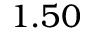<formula> <loc_0><loc_0><loc_500><loc_500>1 . 5 0</formula> 